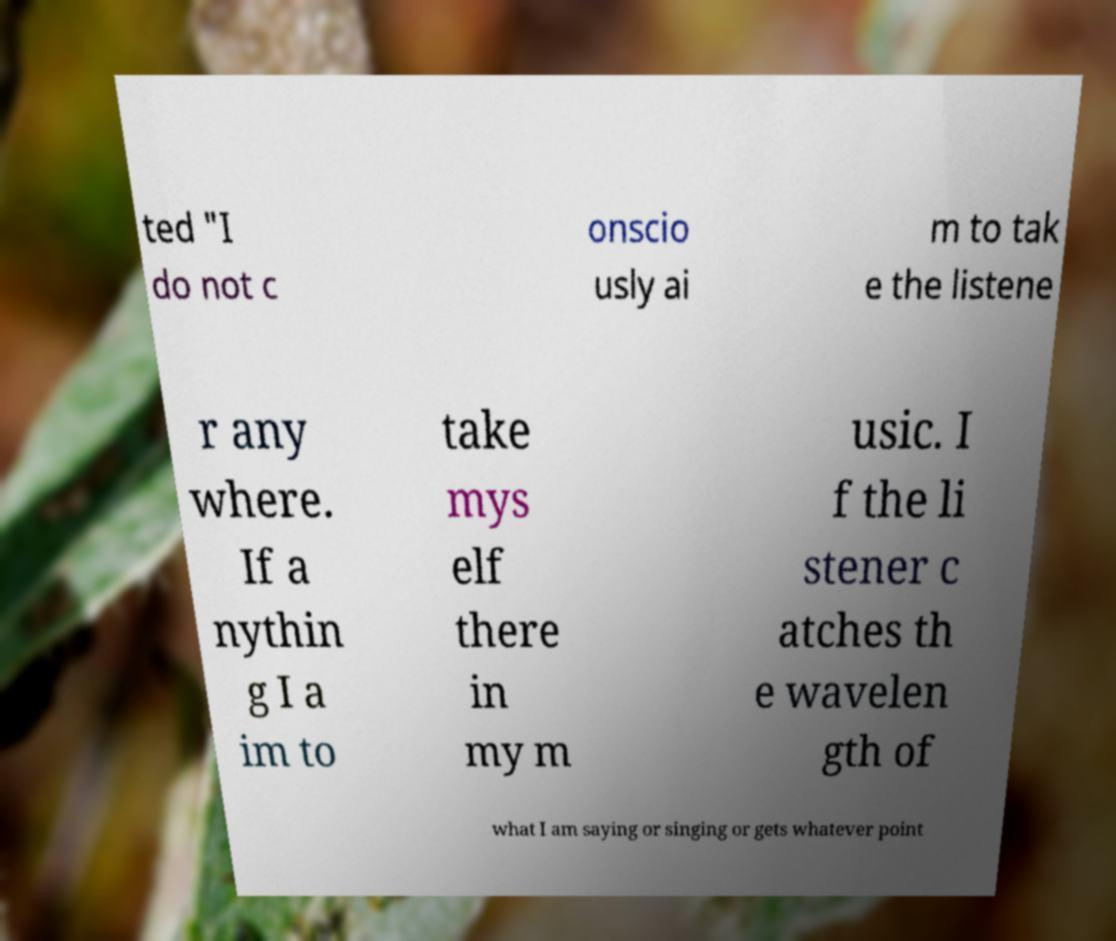There's text embedded in this image that I need extracted. Can you transcribe it verbatim? ted "I do not c onscio usly ai m to tak e the listene r any where. If a nythin g I a im to take mys elf there in my m usic. I f the li stener c atches th e wavelen gth of what I am saying or singing or gets whatever point 